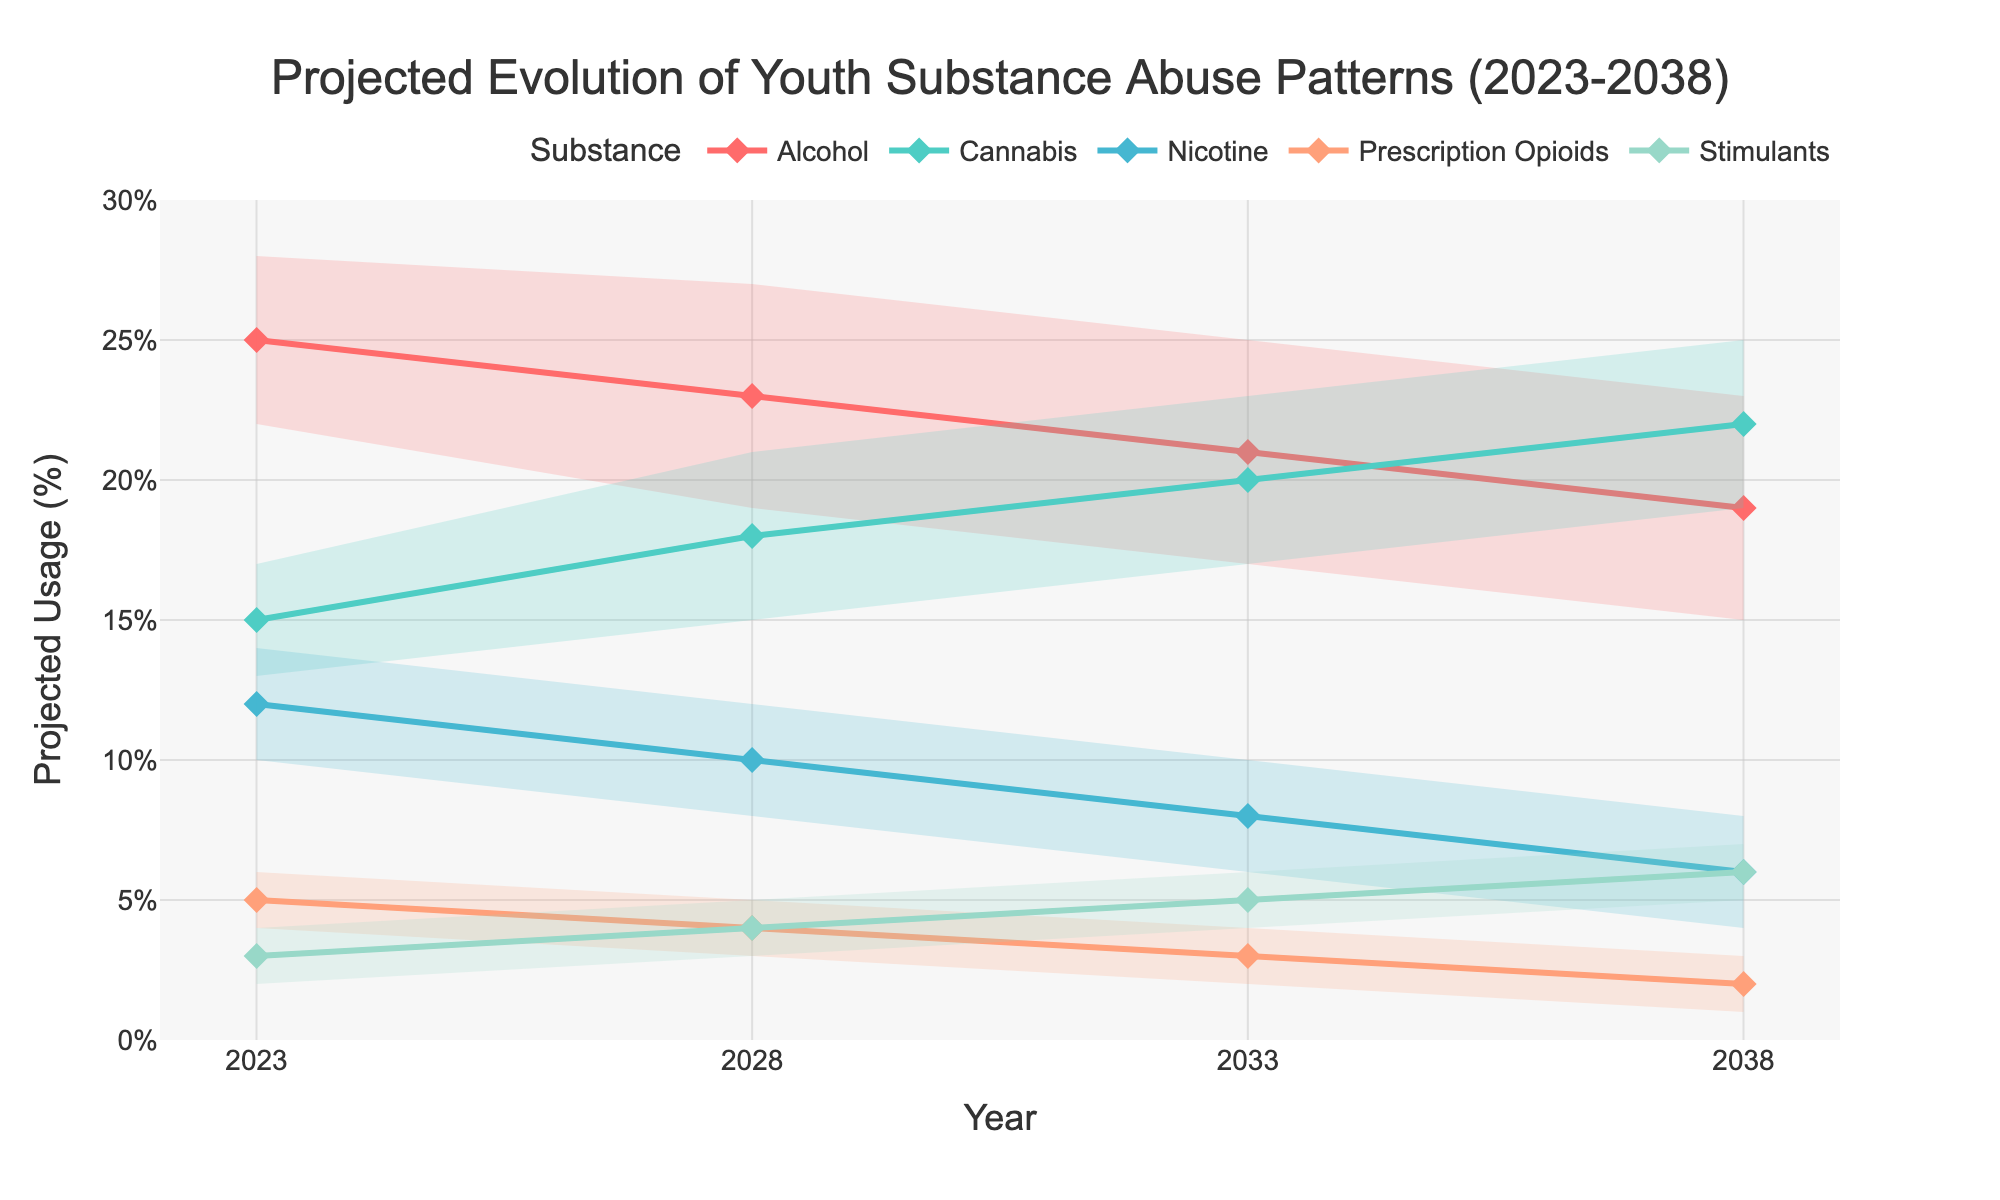What is the projected usage percentage of Cannabis in 2028? The figure shows the projected usage percentages for each substance by year. For Cannabis in 2028, locate the "2028" tick on the x-axis and then identify the point corresponding to Cannabis. The projected usage is written beside the point.
Answer: 18 Which substance shows the greatest increase in projected usage percentage from 2023 to 2038? Determine the difference in projected usage percentages between 2023 and 2038 for each substance. Calculate the increase for each substance: Alcohol (25-19=6), Cannabis (22-15=7), Nicotine (12-6=6), Prescription Opioids (5-2=3), Stimulants (6-3=3). Cannabis has the largest increase.
Answer: Cannabis What is the lower bound of the projected usage percentage for Alcohol in the year 2033? For the year 2033, find the lower edge of the shaded fan area for Alcohol. The lower bound value will be indicated at this point.
Answer: 17 Between what ranges does the projected usage percentage of Stimulants vary in 2023? Locate 2023 on the x-axis and identify the corresponding shaded area for Stimulants. The bottom and top boundaries of this area will give the lower and upper bounds, respectively.
Answer: 2-4 Compare the projected usage percentages of Prescription Opioids and Nicotine in 2033; which is higher? Find the projected usage percentages for 2033 for both Prescription Opioids and Nicotine. Compare the two values directly. Prescription Opioids is 3%, while Nicotine is 8%. Nicotine is higher.
Answer: Nicotine Which substance has the lowest projected usage percentage in 2038? Locate the projected usage percentages for each substance for the year 2038. Identify the minimum value among these. The values are: Alcohol (19), Cannabis (22), Nicotine (6), Prescription Opioids (2), Stimulants (6). Prescription Opioids has the lowest projected usage.
Answer: Prescription Opioids Is the projected usage percentage of Alcohol decreasing, increasing, or stable from 2023 to 2038? Examine the trend of the projected usage percentage line for Alcohol from 2023 to 2038. If it generally slopes downward, it's decreasing; if it slopes upward, it's increasing; if it’s flat, then it’s stable. The graph shows a general downward trend for Alcohol.
Answer: Decreasing For which year does Cannabis have the highest projected usage percentage? Examine the projected usage percentages for Cannabis across all the years shown: 2023 (15), 2028 (18), 2033 (20), 2038 (22). The highest is 22% in 2038.
Answer: 2038 What is the range of projected usage percentages for Nicotine in 2028? Find Nicotine's projected usage percentage for 2028 and its fan chart's lower and upper bounds. The range is from the lower bound to the upper bound in 2028: 8% to 12%.
Answer: 8-12 How does the projected usage percentage of Prescription Opioids change from 2023 to 2038? Track the projected usage percentages for Prescription Opioids across the years. Compare values from 2023 (5%) to 2038 (2%). The usage decreases.
Answer: Decreases 